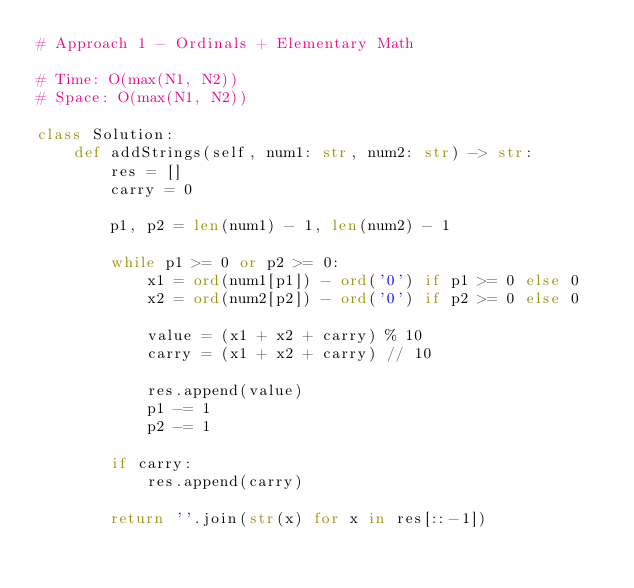<code> <loc_0><loc_0><loc_500><loc_500><_Python_># Approach 1 - Ordinals + Elementary Math

# Time: O(max(N1, N2))
# Space: O(max(N1, N2))

class Solution:
    def addStrings(self, num1: str, num2: str) -> str:
        res = []
        carry = 0
        
        p1, p2 = len(num1) - 1, len(num2) - 1
        
        while p1 >= 0 or p2 >= 0:
            x1 = ord(num1[p1]) - ord('0') if p1 >= 0 else 0
            x2 = ord(num2[p2]) - ord('0') if p2 >= 0 else 0
            
            value = (x1 + x2 + carry) % 10
            carry = (x1 + x2 + carry) // 10
            
            res.append(value)
            p1 -= 1
            p2 -= 1
            
        if carry:
            res.append(carry)
            
        return ''.join(str(x) for x in res[::-1])
        
        </code> 